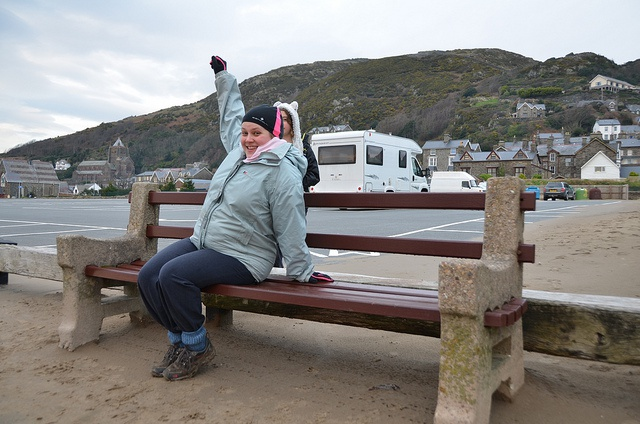Describe the objects in this image and their specific colors. I can see bench in lightblue, gray, darkgray, and maroon tones, people in lightblue, black, darkgray, and gray tones, truck in lightblue, lightgray, gray, and darkgray tones, people in lightblue, black, lightgray, darkgray, and gray tones, and truck in lightblue, lightgray, gray, and darkgray tones in this image. 